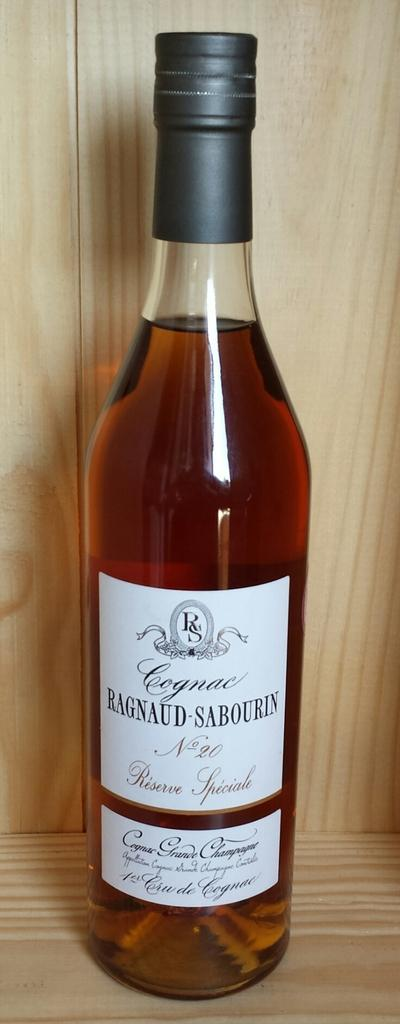<image>
Describe the image concisely. a bottle of Cognac is in a wood case 